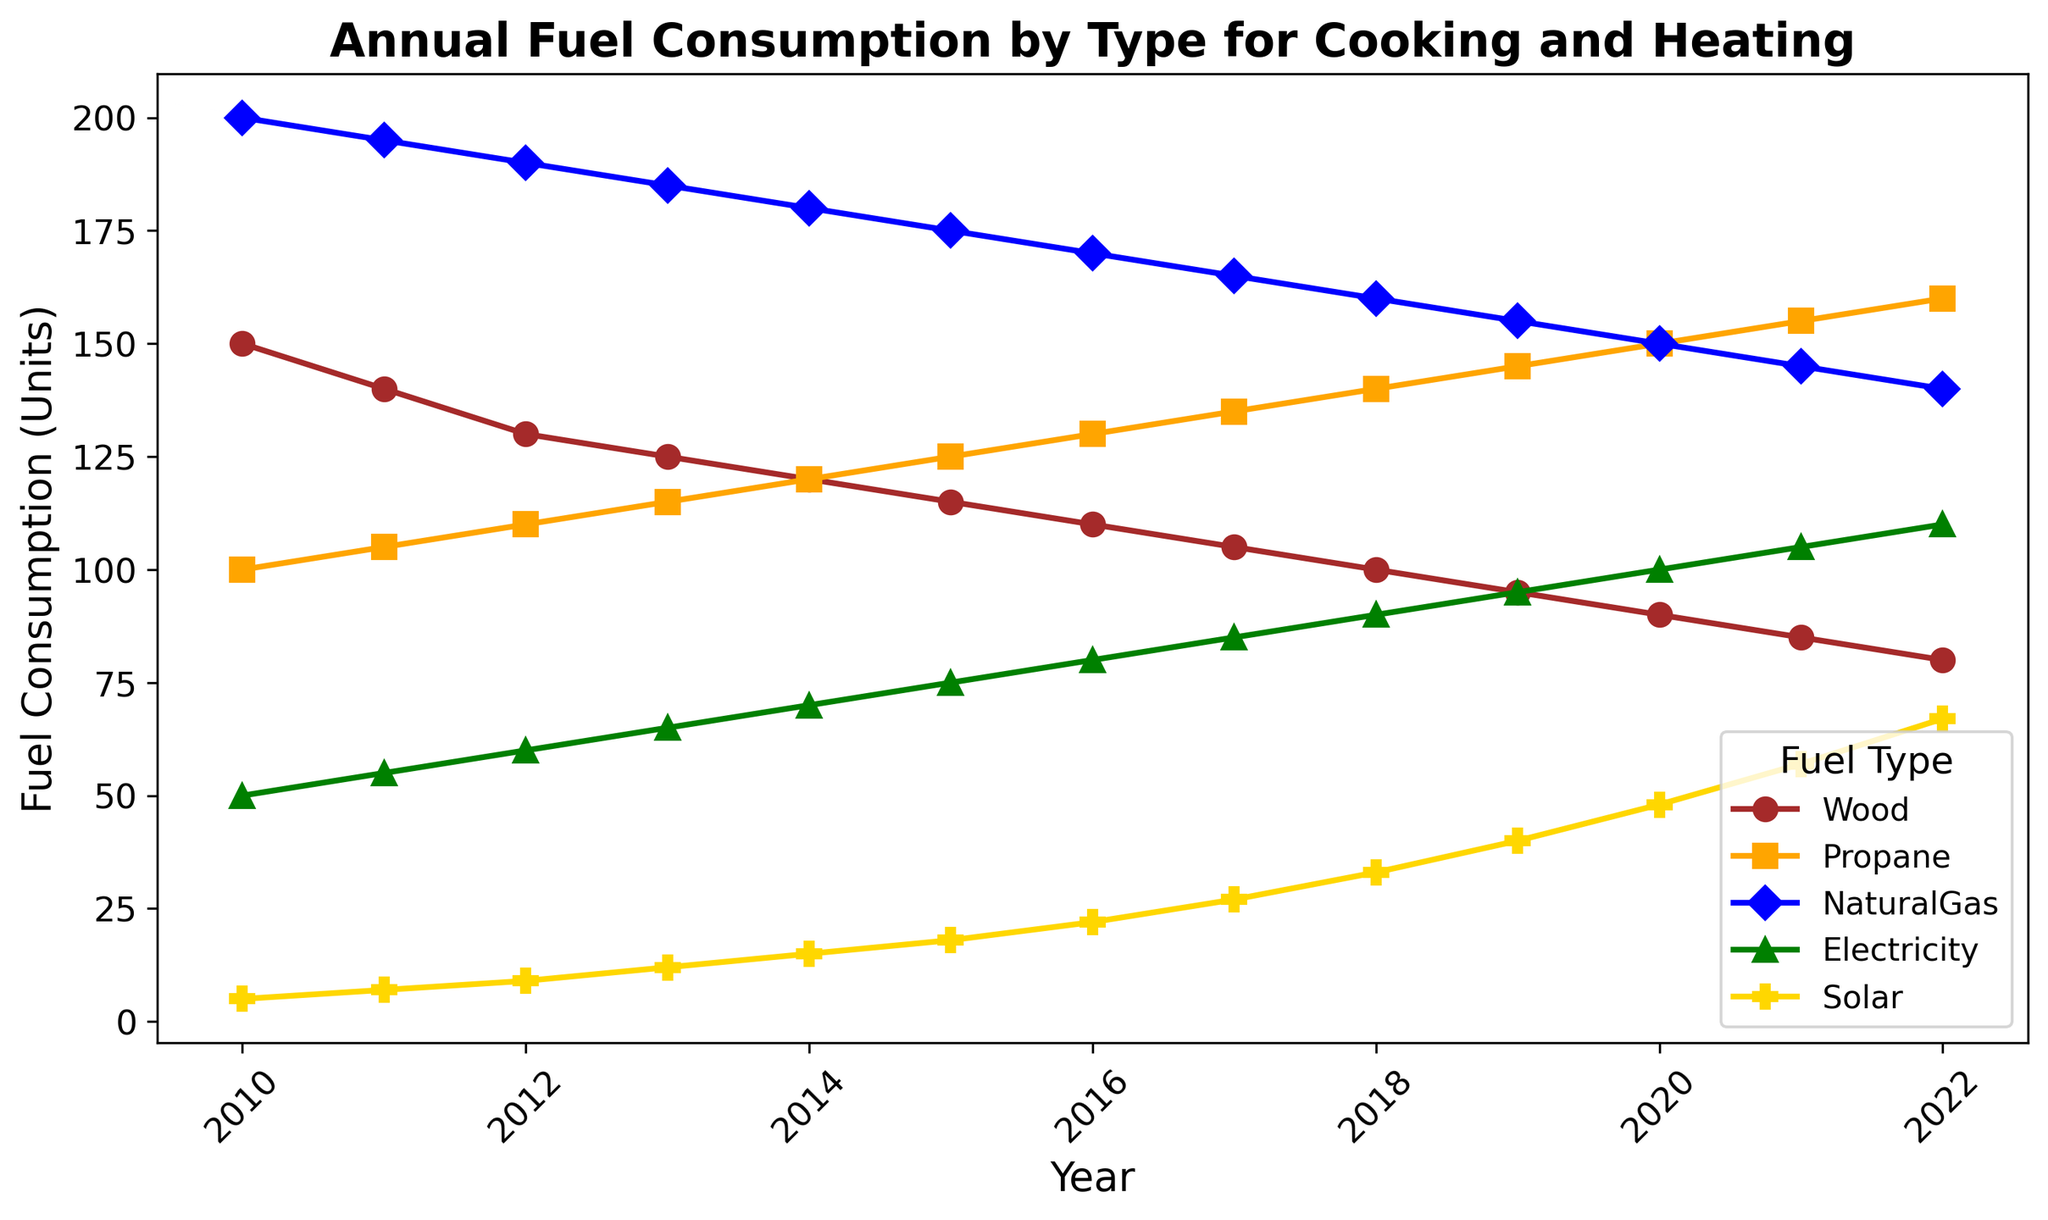What is the general trend of wood consumption from 2010 to 2022? Wood consumption shows a clear decreasing trend from 150 units in 2010 to 80 units in 2022. Each year, the consumption reduces by a small amount.
Answer: Decreasing Compare the consumption of natural gas and solar energy in 2013. Which one is higher and by how much? In 2013, the consumption of natural gas is 185 units, while solar energy is 12 units. The difference between them is 185 - 12 = 173 units.
Answer: Natural gas by 173 units What is the average annual consumption of electricity from 2010 to 2015? From 2010 to 2015, the electricity consumption values are 50, 55, 60, 65, 70, and 75 units. Sum these values to get 50 + 55 + 60 + 65 + 70 + 75 = 375 units. Divide by 6 (number of years) to get the average: 375 / 6 ≈ 62.5 units
Answer: 62.5 units In which year did propane consumption exceed 150 units for the first time, and what was the value in that year? By examining the propane consumption across the years, it is seen that it first exceeded 150 units in 2020 with a consumption of 150 units.
Answer: 2020 with 150 units What is the total fuel consumption for 2015 across all types? In 2015, the values are: Wood: 115, Propane: 125, Natural Gas: 175, Electricity: 75, Solar: 18. Sum these to get the total: 115 + 125 + 175 + 75 + 18 = 508 units.
Answer: 508 units How does the growth of solar energy consumption compare between 2010 and 2022? What is the increase in units? In 2010, solar energy consumption was 5 units, and in 2022, it was 67 units. The increase is 67 - 5 = 62 units.
Answer: 62 units Between 2017 and 2018, which fuel type showed the largest decrease in consumption? By how many units did it decrease? Comparing values between 2017 and 2018: Wood decreases from 105 to 100 (5 units), Propane increases from 135 to 140 (not a decrease), Natural Gas decreases from 165 to 160 (5 units), Electricity increases from 85 to 90 (not a decrease), Solar increases from 27 to 33 (not a decrease). So, both Wood and Natural Gas decreased by 5 units.
Answer: Wood and Natural Gas by 5 units What was the consumption of electricity in 2022 and how does it compare to the solar energy consumption in the same year? In 2022, electricity consumption was 110 units, while solar energy consumption was 67 units. Electricity consumption was 110 - 67 = 43 units higher than solar energy.
Answer: Electricity by 43 units 